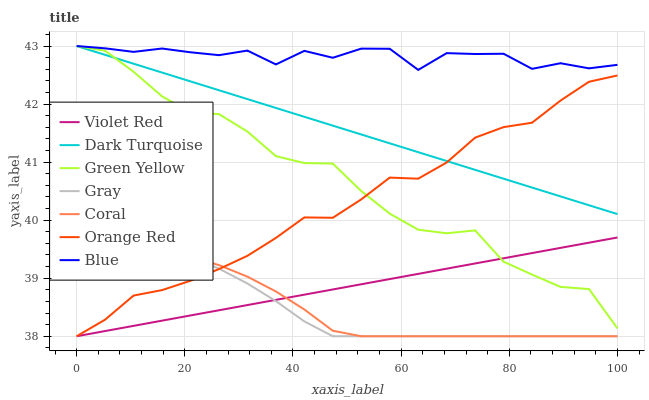Does Coral have the minimum area under the curve?
Answer yes or no. Yes. Does Blue have the maximum area under the curve?
Answer yes or no. Yes. Does Gray have the minimum area under the curve?
Answer yes or no. No. Does Gray have the maximum area under the curve?
Answer yes or no. No. Is Dark Turquoise the smoothest?
Answer yes or no. Yes. Is Blue the roughest?
Answer yes or no. Yes. Is Gray the smoothest?
Answer yes or no. No. Is Gray the roughest?
Answer yes or no. No. Does Dark Turquoise have the lowest value?
Answer yes or no. No. Does Gray have the highest value?
Answer yes or no. No. Is Gray less than Blue?
Answer yes or no. Yes. Is Blue greater than Gray?
Answer yes or no. Yes. Does Gray intersect Blue?
Answer yes or no. No. 